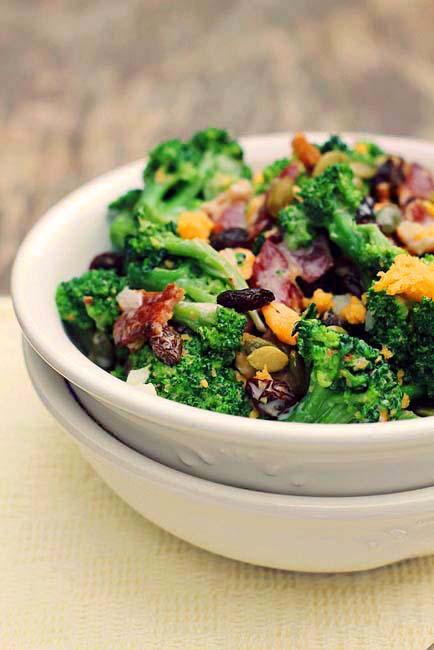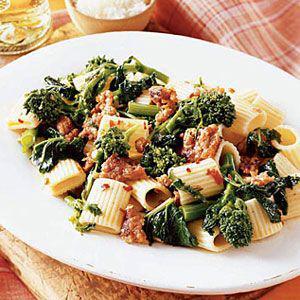The first image is the image on the left, the second image is the image on the right. Evaluate the accuracy of this statement regarding the images: "Left image shows food served in a rectangular dish.". Is it true? Answer yes or no. No. The first image is the image on the left, the second image is the image on the right. Considering the images on both sides, is "At least one dish has pasta in it." valid? Answer yes or no. Yes. 